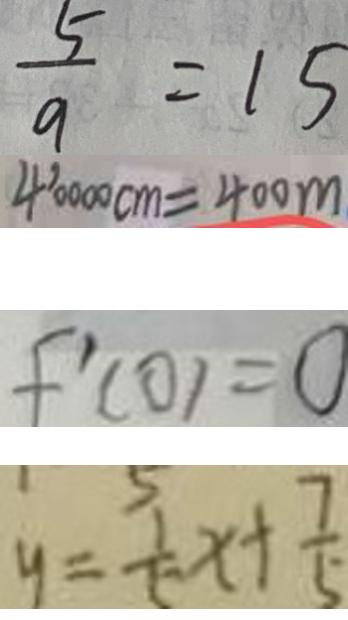<formula> <loc_0><loc_0><loc_500><loc_500>\frac { 5 } { 9 } = 1 5 
 4 0 0 0 0 c m = 4 0 0 m 
 f ^ { \prime } ( 0 ) = 0 
 y = \frac { 1 } { 5 } x + \frac { 7 } { 5 }</formula> 